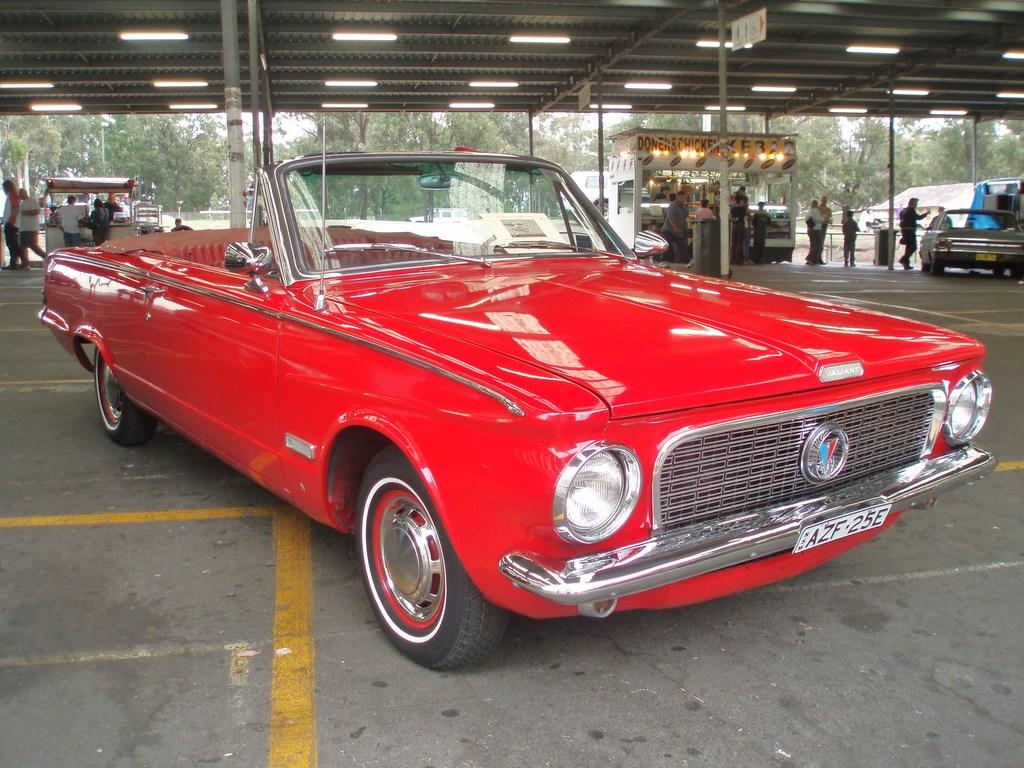What can be seen on the road in the image? There are vehicles on the road in the image. What is visible in the background of the image? In the background of the image, there are sheds, people, lights, poles, boards, and trees. Can you describe the roof visible at the top of the image? The roof visible at the top of the image is part of the background. What type of wristwatch is the dad wearing in the image? There is no dad or wristwatch present in the image. What scene is depicted in the image? The image does not depict a scene; it shows vehicles on a road with a background containing various elements. 